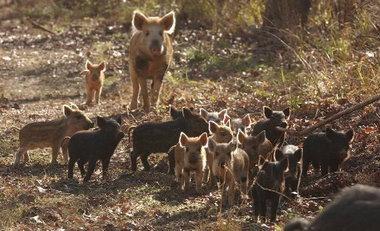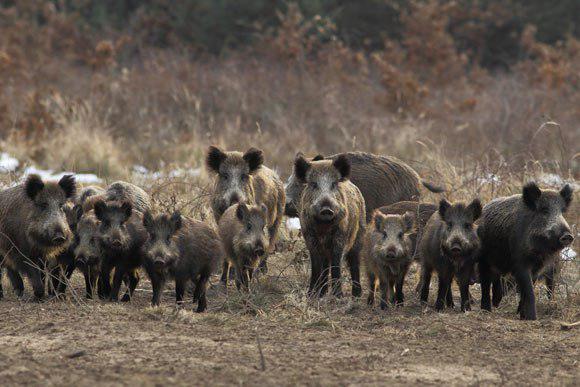The first image is the image on the left, the second image is the image on the right. Assess this claim about the two images: "The animals in one of the images are moving directly toward the camera.". Correct or not? Answer yes or no. Yes. 